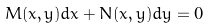<formula> <loc_0><loc_0><loc_500><loc_500>M ( x , y ) d x + N ( x , y ) d y = 0</formula> 